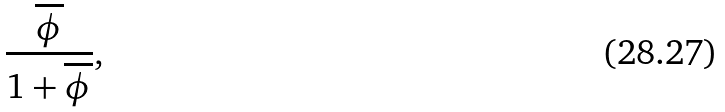<formula> <loc_0><loc_0><loc_500><loc_500>\frac { \overline { \phi } } { 1 + \overline { \phi } } ,</formula> 